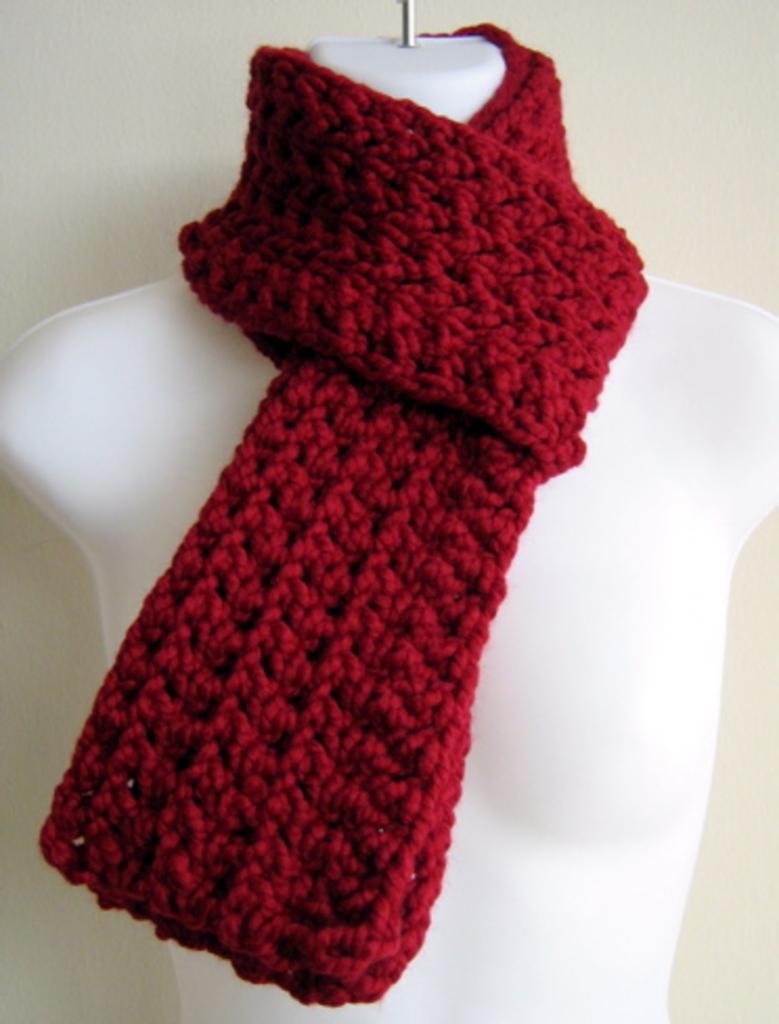How would you summarize this image in a sentence or two? In the image in the center we can see one mannequin and one red woolen scarf. In the background there is a wall. 